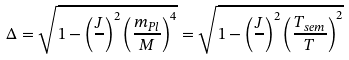Convert formula to latex. <formula><loc_0><loc_0><loc_500><loc_500>\Delta = \sqrt { 1 - \left ( \frac { J } { } \right ) ^ { 2 } \left ( \frac { m _ { P l } } { M } \right ) ^ { 4 } } = \sqrt { 1 - \left ( \frac { J } { } \right ) ^ { 2 } \left ( \frac { T _ { s e m } } { T } \right ) ^ { 2 } }</formula> 